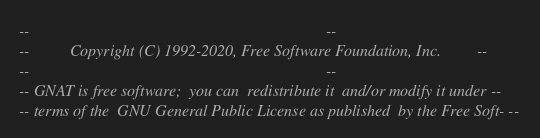<code> <loc_0><loc_0><loc_500><loc_500><_Ada_>--                                                                          --
--          Copyright (C) 1992-2020, Free Software Foundation, Inc.         --
--                                                                          --
-- GNAT is free software;  you can  redistribute it  and/or modify it under --
-- terms of the  GNU General Public License as published  by the Free Soft- --</code> 